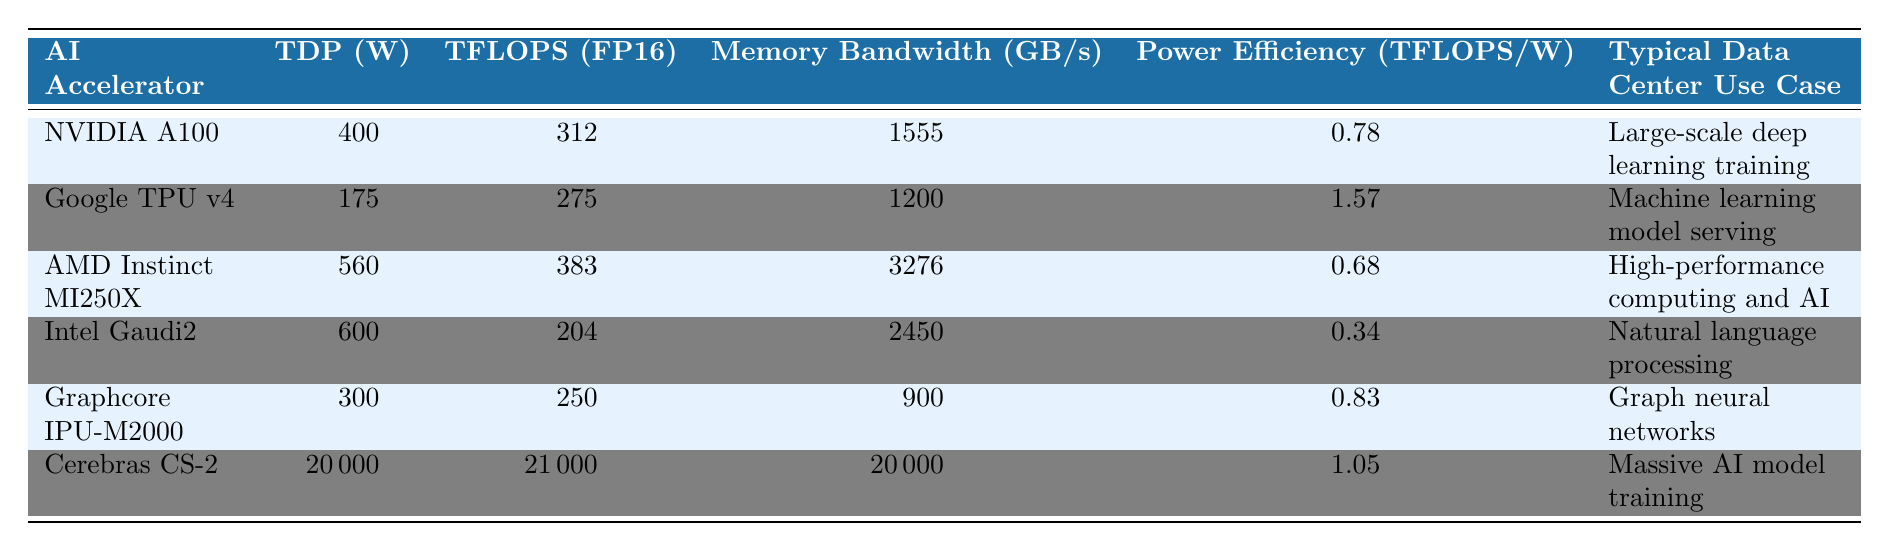What is the TDP value for the Google TPU v4? The table directly shows that the TDP value for the Google TPU v4 is listed as 175 W.
Answer: 175 W Which AI accelerator has the highest power efficiency? The table lists the power efficiency for each accelerator, with the Google TPU v4 showing 1.57 TFLOPS/W as the highest value.
Answer: Google TPU v4 How does the TDP of the eAI Accelerator compare to that of AMD Instinct MI250X? The TDP of eAI Accelerator is 600 W while AMD Instinct MI250X has a TDP of 560 W. The difference in TDP is 600 W - 560 W = 40 W, showing that eAI Accelerator has a higher TDP by 40 W.
Answer: eAI Accelerator has 40 W higher TDP What is the average memory bandwidth of the AI accelerators listed? The individual memory bandwidth values are: 1555, 1200, 3276, 2450, 900, and 20000 GB/s. Adding these gives a total of 27481 GB/s. There are 6 accelerators, so the average is 27481 / 6 = 4579 GB/s.
Answer: 4579 GB/s Is the NVIDIA A100 more power efficient than the Intel Gaudi2? Comparing the power efficiencies, the NVIDIA A100 has 0.78 TFLOPS/W while Intel Gaudi2 has 0.34 TFLOPS/W. Since 0.78 is greater than 0.34, NVIDIA A100 is indeed more power efficient.
Answer: Yes Which accelerator is designed for large-scale deep learning training, and what’s its TDP? The table indicates that the NVIDIA A100 is designed for large-scale deep learning training and has a TDP of 400 W.
Answer: NVIDIA A100; 400 W What is the memory bandwidth difference between the AMD Instinct MI250X and the Graphcore IPU-M2000? The memory bandwidth for AMD Instinct MI250X is 3276 GB/s, while for Graphcore IPU-M2000 it is 900 GB/s. The difference is 3276 GB/s - 900 GB/s = 2376 GB/s, indicating the AMD Instinct MI250X has higher memory bandwidth.
Answer: 2376 GB/s How much more TFLOPS can the Cerebras CS-2 achieve compared to the Intel Gaudi2? Cerebras CS-2 has 21000 TFLOPS, while Intel Gaudi2 has 204 TFLOPS. The difference is 21000 - 204 = 20796 TFLOPS, meaning Cerebras CS-2 significantly outperforms Intel Gaudi2 in TFLOPS.
Answer: 20796 TFLOPS Is it correct to say that the Graphcore IPU-M2000 uses less than 400 W? The TDP for Graphcore IPU-M2000 is 300 W, which is indeed less than 400 W; hence the statement is correct.
Answer: Yes 